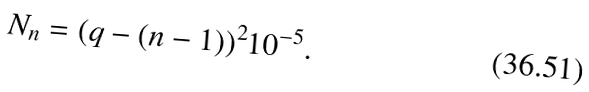<formula> <loc_0><loc_0><loc_500><loc_500>N _ { n } = ( q - ( n - 1 ) ) ^ { 2 } 1 0 ^ { - 5 } .</formula> 